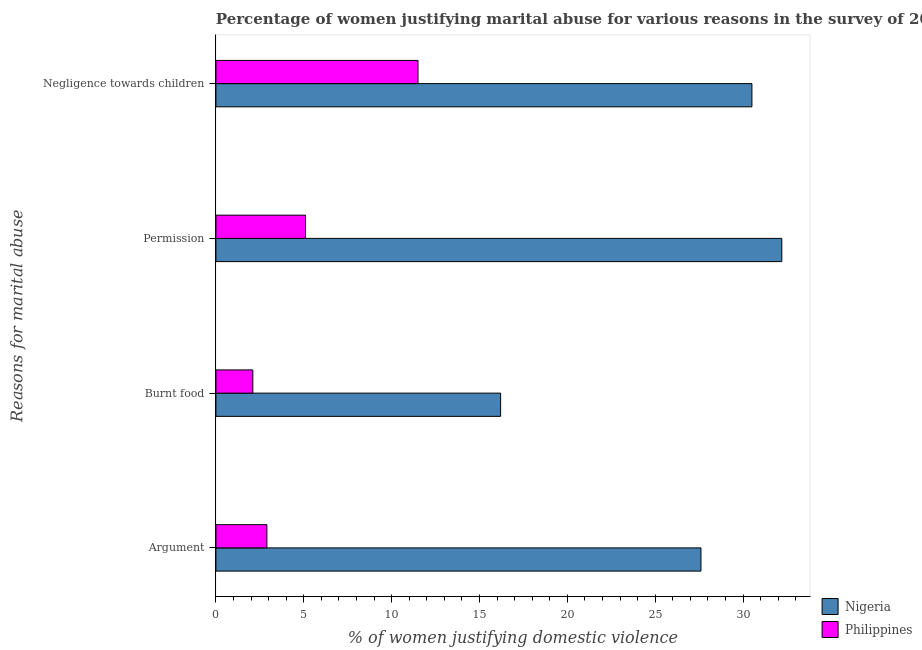Are the number of bars per tick equal to the number of legend labels?
Your answer should be compact. Yes. Are the number of bars on each tick of the Y-axis equal?
Provide a succinct answer. Yes. What is the label of the 1st group of bars from the top?
Ensure brevity in your answer.  Negligence towards children. Across all countries, what is the minimum percentage of women justifying abuse for showing negligence towards children?
Offer a very short reply. 11.5. In which country was the percentage of women justifying abuse for burning food maximum?
Provide a succinct answer. Nigeria. What is the difference between the percentage of women justifying abuse for going without permission in Nigeria and that in Philippines?
Make the answer very short. 27.1. What is the difference between the percentage of women justifying abuse for burning food in Philippines and the percentage of women justifying abuse in the case of an argument in Nigeria?
Make the answer very short. -25.5. What is the average percentage of women justifying abuse in the case of an argument per country?
Give a very brief answer. 15.25. In how many countries, is the percentage of women justifying abuse for burning food greater than 17 %?
Your response must be concise. 0. What is the ratio of the percentage of women justifying abuse for showing negligence towards children in Philippines to that in Nigeria?
Offer a very short reply. 0.38. Is the difference between the percentage of women justifying abuse for burning food in Nigeria and Philippines greater than the difference between the percentage of women justifying abuse for showing negligence towards children in Nigeria and Philippines?
Ensure brevity in your answer.  No. What is the difference between the highest and the lowest percentage of women justifying abuse in the case of an argument?
Offer a terse response. 24.7. Is the sum of the percentage of women justifying abuse in the case of an argument in Nigeria and Philippines greater than the maximum percentage of women justifying abuse for going without permission across all countries?
Provide a short and direct response. No. What does the 2nd bar from the top in Argument represents?
Your answer should be very brief. Nigeria. What does the 1st bar from the bottom in Burnt food represents?
Your response must be concise. Nigeria. Is it the case that in every country, the sum of the percentage of women justifying abuse in the case of an argument and percentage of women justifying abuse for burning food is greater than the percentage of women justifying abuse for going without permission?
Make the answer very short. No. How many bars are there?
Keep it short and to the point. 8. Are the values on the major ticks of X-axis written in scientific E-notation?
Keep it short and to the point. No. Does the graph contain grids?
Offer a terse response. No. Where does the legend appear in the graph?
Provide a succinct answer. Bottom right. How many legend labels are there?
Provide a short and direct response. 2. How are the legend labels stacked?
Your answer should be very brief. Vertical. What is the title of the graph?
Give a very brief answer. Percentage of women justifying marital abuse for various reasons in the survey of 2008. What is the label or title of the X-axis?
Make the answer very short. % of women justifying domestic violence. What is the label or title of the Y-axis?
Your answer should be very brief. Reasons for marital abuse. What is the % of women justifying domestic violence in Nigeria in Argument?
Offer a terse response. 27.6. What is the % of women justifying domestic violence of Philippines in Argument?
Provide a short and direct response. 2.9. What is the % of women justifying domestic violence in Nigeria in Burnt food?
Offer a very short reply. 16.2. What is the % of women justifying domestic violence of Philippines in Burnt food?
Your response must be concise. 2.1. What is the % of women justifying domestic violence of Nigeria in Permission?
Provide a succinct answer. 32.2. What is the % of women justifying domestic violence of Philippines in Permission?
Your answer should be compact. 5.1. What is the % of women justifying domestic violence of Nigeria in Negligence towards children?
Your answer should be compact. 30.5. Across all Reasons for marital abuse, what is the maximum % of women justifying domestic violence of Nigeria?
Keep it short and to the point. 32.2. Across all Reasons for marital abuse, what is the minimum % of women justifying domestic violence in Nigeria?
Your answer should be very brief. 16.2. What is the total % of women justifying domestic violence of Nigeria in the graph?
Offer a terse response. 106.5. What is the total % of women justifying domestic violence in Philippines in the graph?
Your answer should be compact. 21.6. What is the difference between the % of women justifying domestic violence of Nigeria in Argument and that in Burnt food?
Provide a succinct answer. 11.4. What is the difference between the % of women justifying domestic violence in Nigeria in Argument and that in Negligence towards children?
Ensure brevity in your answer.  -2.9. What is the difference between the % of women justifying domestic violence of Nigeria in Burnt food and that in Permission?
Give a very brief answer. -16. What is the difference between the % of women justifying domestic violence of Philippines in Burnt food and that in Permission?
Offer a very short reply. -3. What is the difference between the % of women justifying domestic violence in Nigeria in Burnt food and that in Negligence towards children?
Provide a succinct answer. -14.3. What is the difference between the % of women justifying domestic violence of Nigeria in Burnt food and the % of women justifying domestic violence of Philippines in Negligence towards children?
Your response must be concise. 4.7. What is the difference between the % of women justifying domestic violence of Nigeria in Permission and the % of women justifying domestic violence of Philippines in Negligence towards children?
Ensure brevity in your answer.  20.7. What is the average % of women justifying domestic violence of Nigeria per Reasons for marital abuse?
Offer a terse response. 26.62. What is the difference between the % of women justifying domestic violence in Nigeria and % of women justifying domestic violence in Philippines in Argument?
Offer a terse response. 24.7. What is the difference between the % of women justifying domestic violence of Nigeria and % of women justifying domestic violence of Philippines in Permission?
Your response must be concise. 27.1. What is the difference between the % of women justifying domestic violence of Nigeria and % of women justifying domestic violence of Philippines in Negligence towards children?
Your answer should be very brief. 19. What is the ratio of the % of women justifying domestic violence in Nigeria in Argument to that in Burnt food?
Provide a short and direct response. 1.7. What is the ratio of the % of women justifying domestic violence of Philippines in Argument to that in Burnt food?
Keep it short and to the point. 1.38. What is the ratio of the % of women justifying domestic violence in Nigeria in Argument to that in Permission?
Make the answer very short. 0.86. What is the ratio of the % of women justifying domestic violence of Philippines in Argument to that in Permission?
Your response must be concise. 0.57. What is the ratio of the % of women justifying domestic violence in Nigeria in Argument to that in Negligence towards children?
Make the answer very short. 0.9. What is the ratio of the % of women justifying domestic violence of Philippines in Argument to that in Negligence towards children?
Offer a terse response. 0.25. What is the ratio of the % of women justifying domestic violence in Nigeria in Burnt food to that in Permission?
Provide a succinct answer. 0.5. What is the ratio of the % of women justifying domestic violence in Philippines in Burnt food to that in Permission?
Provide a short and direct response. 0.41. What is the ratio of the % of women justifying domestic violence of Nigeria in Burnt food to that in Negligence towards children?
Ensure brevity in your answer.  0.53. What is the ratio of the % of women justifying domestic violence of Philippines in Burnt food to that in Negligence towards children?
Offer a terse response. 0.18. What is the ratio of the % of women justifying domestic violence in Nigeria in Permission to that in Negligence towards children?
Ensure brevity in your answer.  1.06. What is the ratio of the % of women justifying domestic violence in Philippines in Permission to that in Negligence towards children?
Keep it short and to the point. 0.44. 